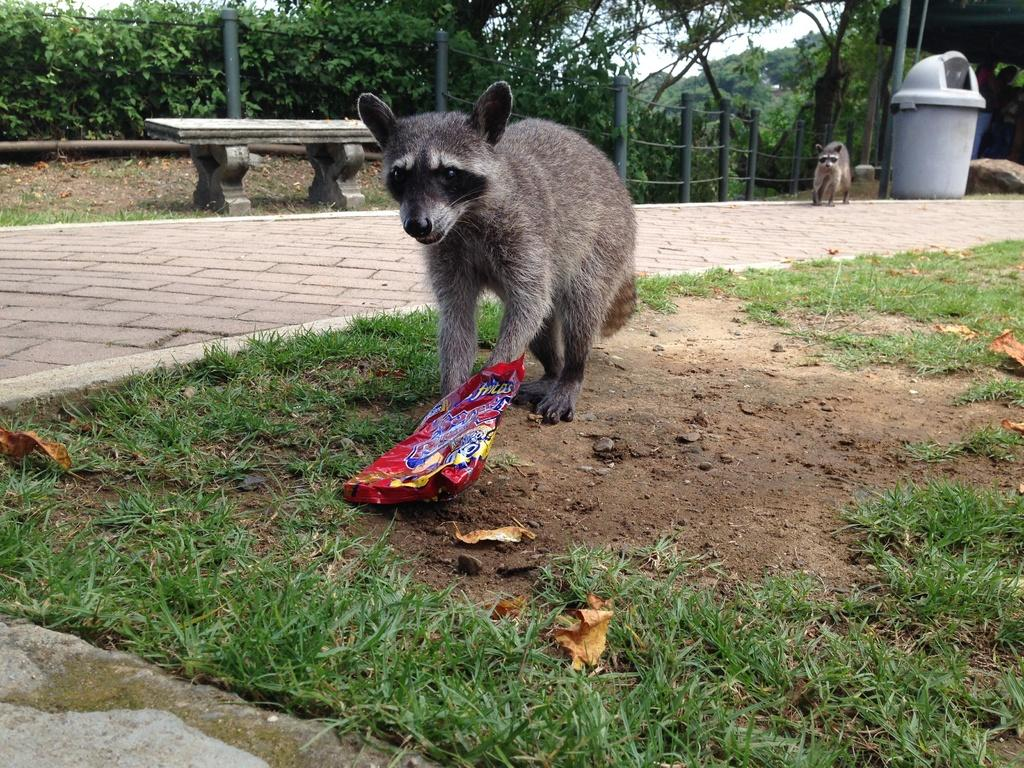How many animals are present in the image? There are two animals in the image. What is on the ground in the image? There is grass and a packet on the ground. What type of surface can be seen in the image? There is a sidewalk in the image. What type of seating is available in the image? There is a bench in the image. What is used for waste disposal in the image? There is a dustbin in the image. What can be seen in the background of the image? There are poles and trees in the background of the image. What type of hair can be seen on the animals in the image? There is no hair visible on the animals in the image, as the animals are not mammals. --- Facts: 1. There is a person holding a book in the image. 2. The person is sitting on a chair. 3. There is a table in the image. 4. There is a lamp on the table. 5. There is a window in the image. 6. There is a curtain associated with the window. Absurd Topics: elephant, ocean, bicycle Conversation: What is the person in the image holding? The person is holding a book in the image. Where is the person sitting in the image? The person is sitting on a chair in the image. What type of furniture is present in the image? There is a table in the image. What is on the table in the image? There is a lamp on the table in the image. What can be seen in the background of the image? There is a window and a curtain associated with the window in the image. Reasoning: Let's think step by step in order to produce the conversation. We start by identifying the main subject in the image, which is the person holding a book. Then, we expand the conversation to include other items and structures that are also visible, such as the chair, table, lamp, window, and curtain. Each question is designed to elicit a specific detail about the image that is known from the provided facts. Absurd Question/Answer: Can you see an elephant swimming in the ocean in the image? No, there is no elephant or ocean present in the image. 